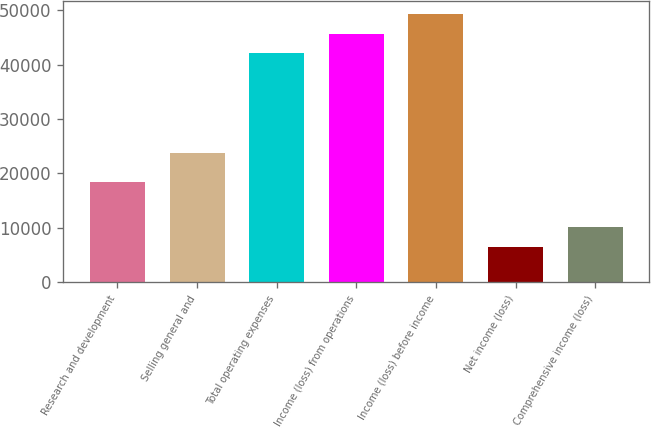<chart> <loc_0><loc_0><loc_500><loc_500><bar_chart><fcel>Research and development<fcel>Selling general and<fcel>Total operating expenses<fcel>Income (loss) from operations<fcel>Income (loss) before income<fcel>Net income (loss)<fcel>Comprehensive income (loss)<nl><fcel>18335<fcel>23776<fcel>42111<fcel>45673.9<fcel>49236.8<fcel>6482<fcel>10044.9<nl></chart> 